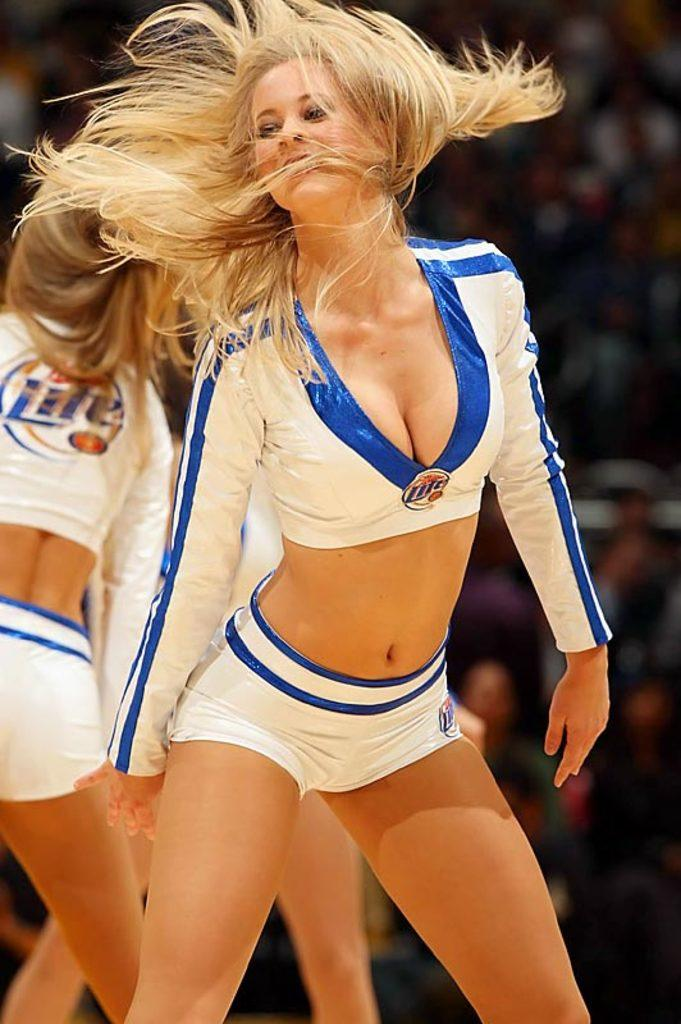<image>
Provide a brief description of the given image. Cheerleader on the floor wearing a top which says Lite on it. 